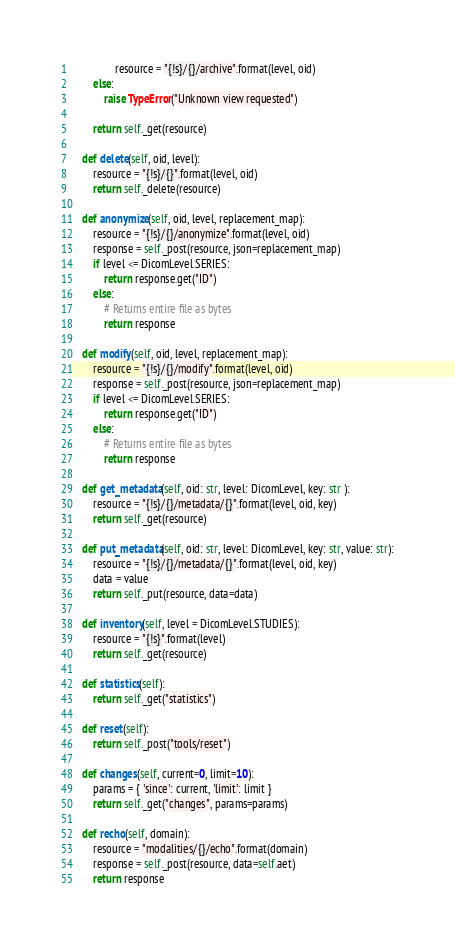Convert code to text. <code><loc_0><loc_0><loc_500><loc_500><_Python_>                resource = "{!s}/{}/archive".format(level, oid)
        else:
            raise TypeError("Unknown view requested")

        return self._get(resource)

    def delete(self, oid, level):
        resource = "{!s}/{}".format(level, oid)
        return self._delete(resource)

    def anonymize(self, oid, level, replacement_map):
        resource = "{!s}/{}/anonymize".format(level, oid)
        response = self._post(resource, json=replacement_map)
        if level <= DicomLevel.SERIES:
            return response.get("ID")
        else:
            # Returns entire file as bytes
            return response

    def modify(self, oid, level, replacement_map):
        resource = "{!s}/{}/modify".format(level, oid)
        response = self._post(resource, json=replacement_map)
        if level <= DicomLevel.SERIES:
            return response.get("ID")
        else:
            # Returns entire file as bytes
            return response

    def get_metadata(self, oid: str, level: DicomLevel, key: str ):
        resource = "{!s}/{}/metadata/{}".format(level, oid, key)
        return self._get(resource)

    def put_metadata(self, oid: str, level: DicomLevel, key: str, value: str):
        resource = "{!s}/{}/metadata/{}".format(level, oid, key)
        data = value
        return self._put(resource, data=data)

    def inventory(self, level = DicomLevel.STUDIES):
        resource = "{!s}".format(level)
        return self._get(resource)

    def statistics(self):
        return self._get("statistics")

    def reset(self):
        return self._post("tools/reset")

    def changes(self, current=0, limit=10):
        params = { 'since': current, 'limit': limit }
        return self._get("changes", params=params)

    def recho(self, domain):
        resource = "modalities/{}/echo".format(domain)
        response = self._post(resource, data=self.aet)
        return response
</code> 